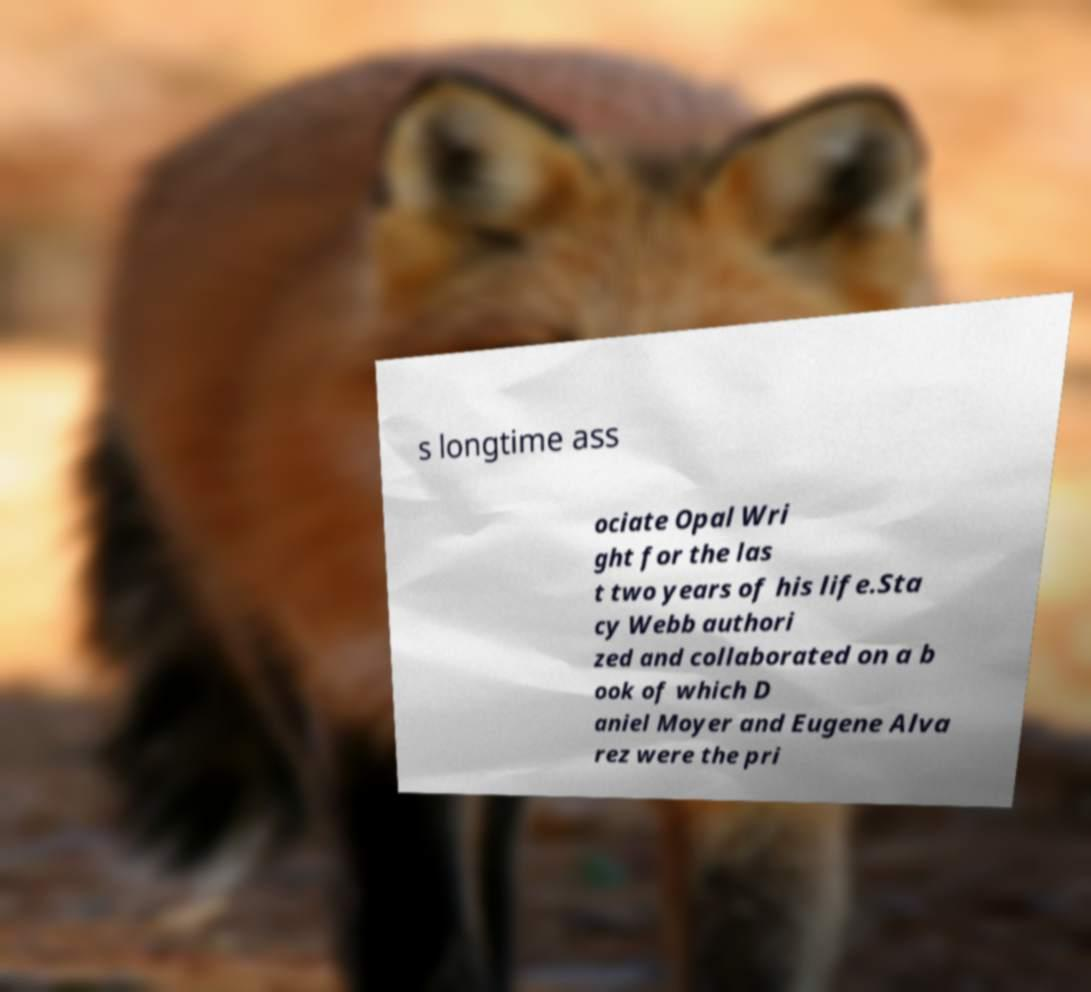Please read and relay the text visible in this image. What does it say? s longtime ass ociate Opal Wri ght for the las t two years of his life.Sta cy Webb authori zed and collaborated on a b ook of which D aniel Moyer and Eugene Alva rez were the pri 